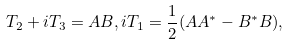Convert formula to latex. <formula><loc_0><loc_0><loc_500><loc_500>T _ { 2 } + i T _ { 3 } = A B , i T _ { 1 } = \frac { 1 } { 2 } ( A A ^ { \ast } - B ^ { \ast } B ) ,</formula> 